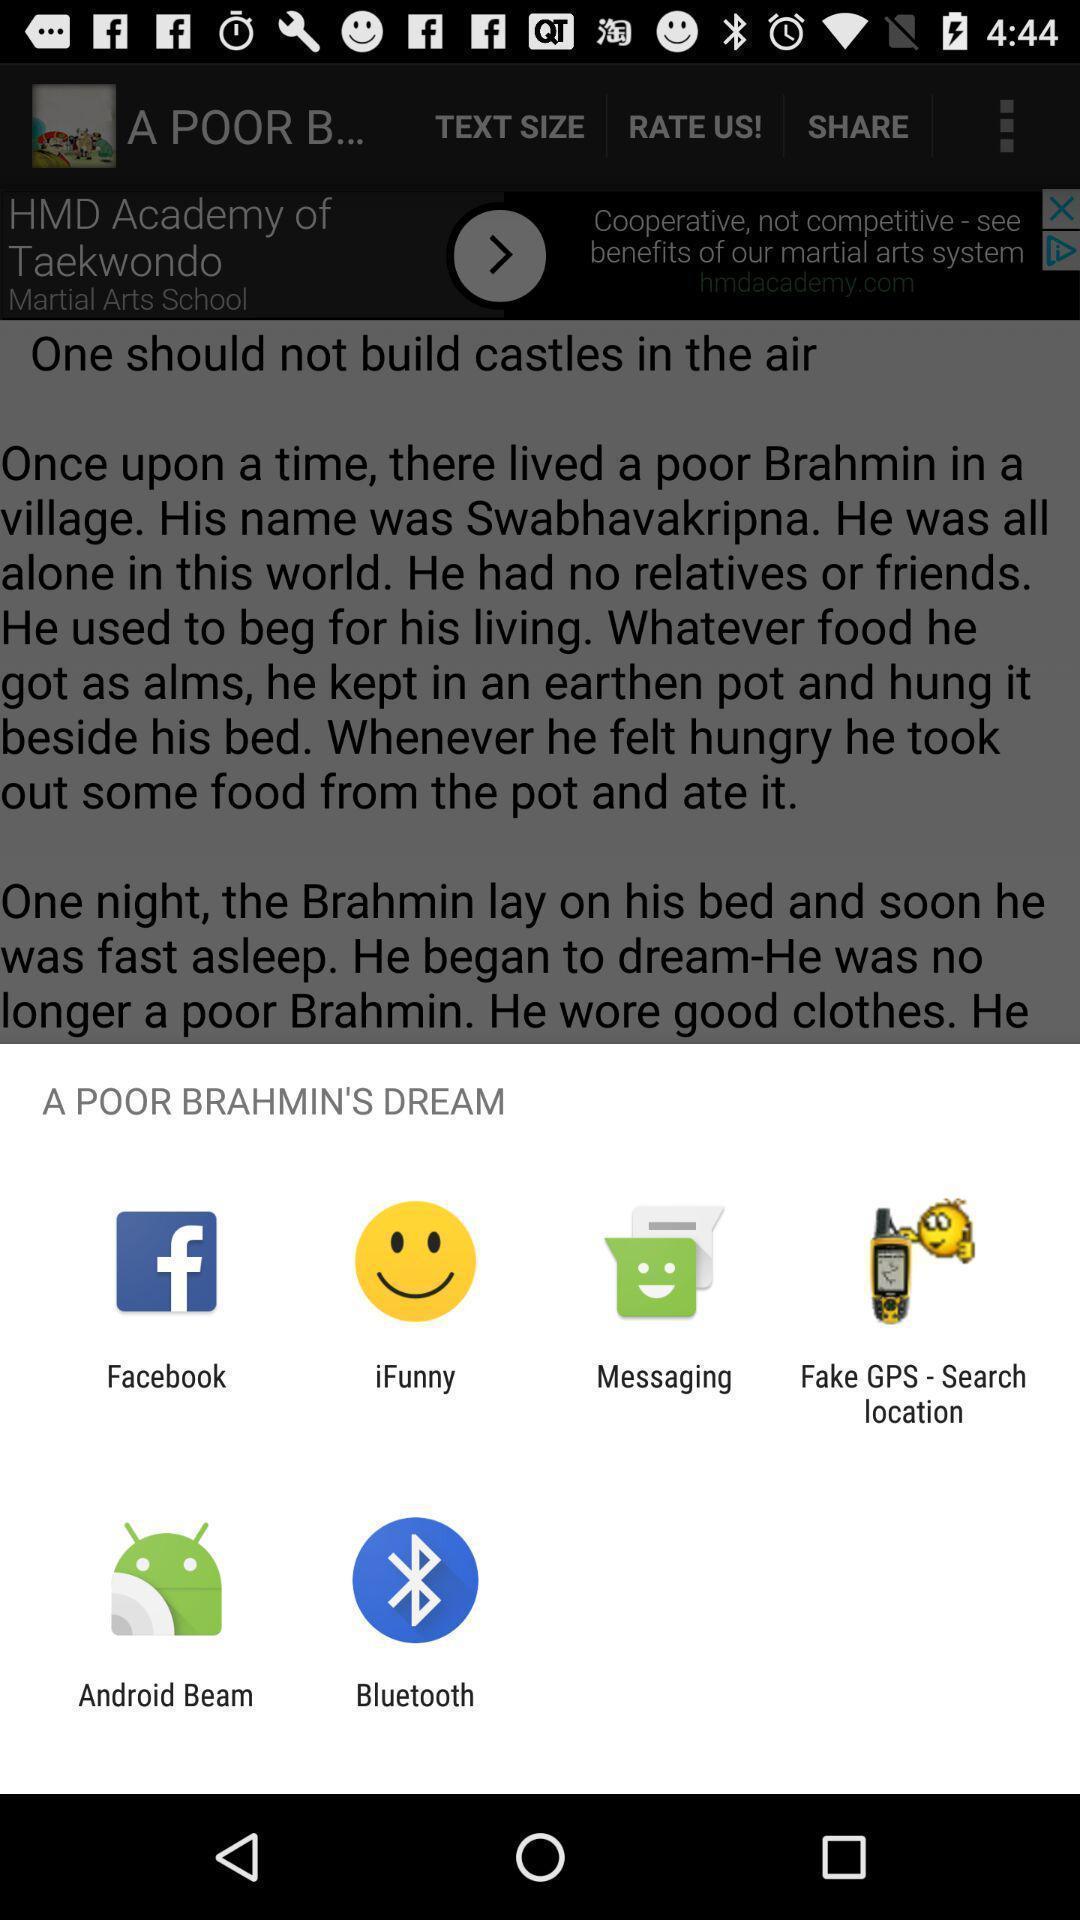Please provide a description for this image. Push up page showing app preference to share. 